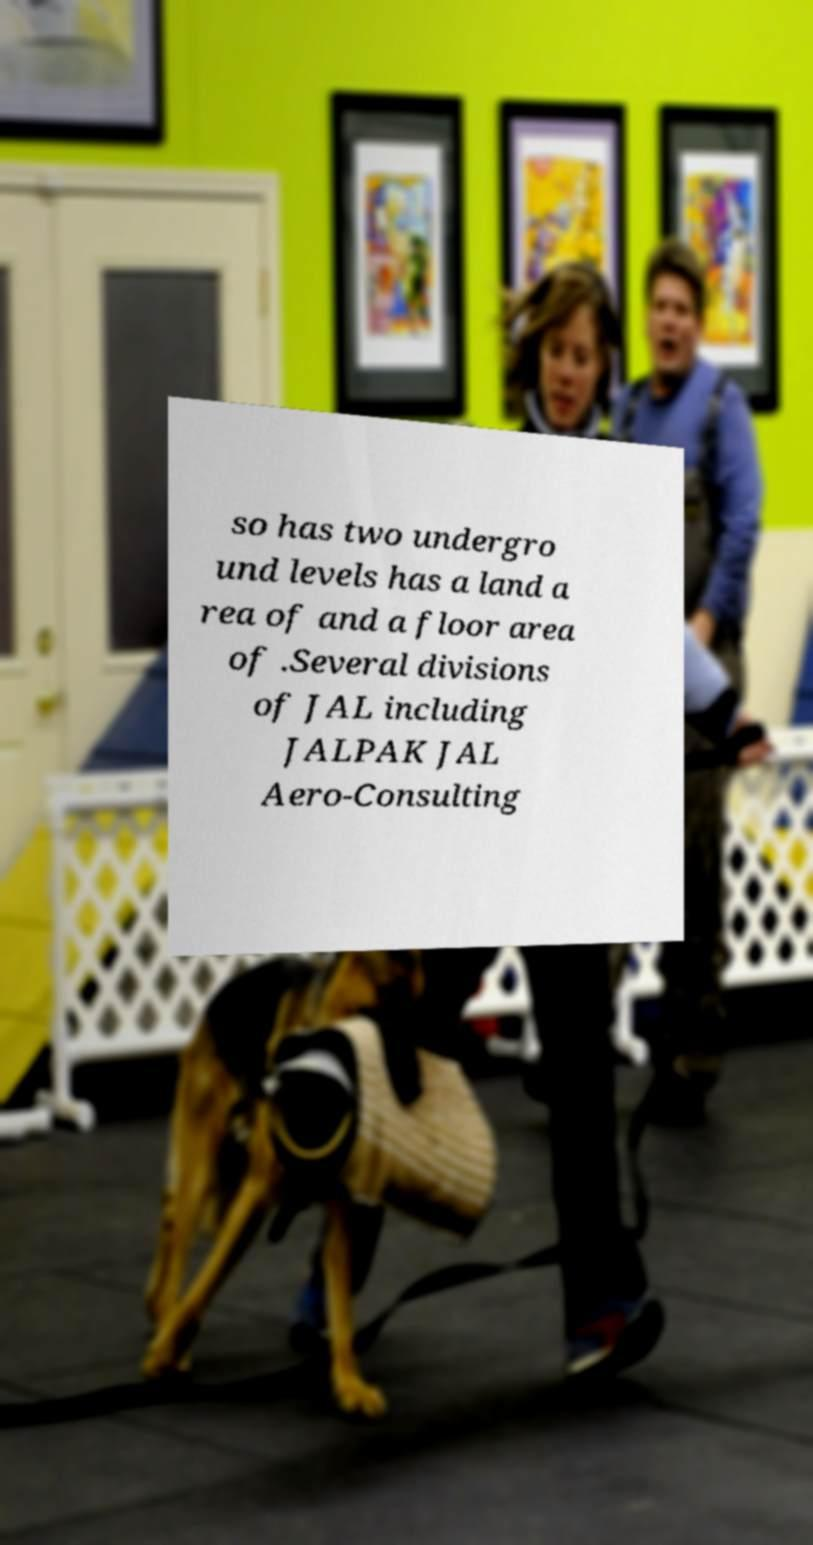What messages or text are displayed in this image? I need them in a readable, typed format. so has two undergro und levels has a land a rea of and a floor area of .Several divisions of JAL including JALPAK JAL Aero-Consulting 